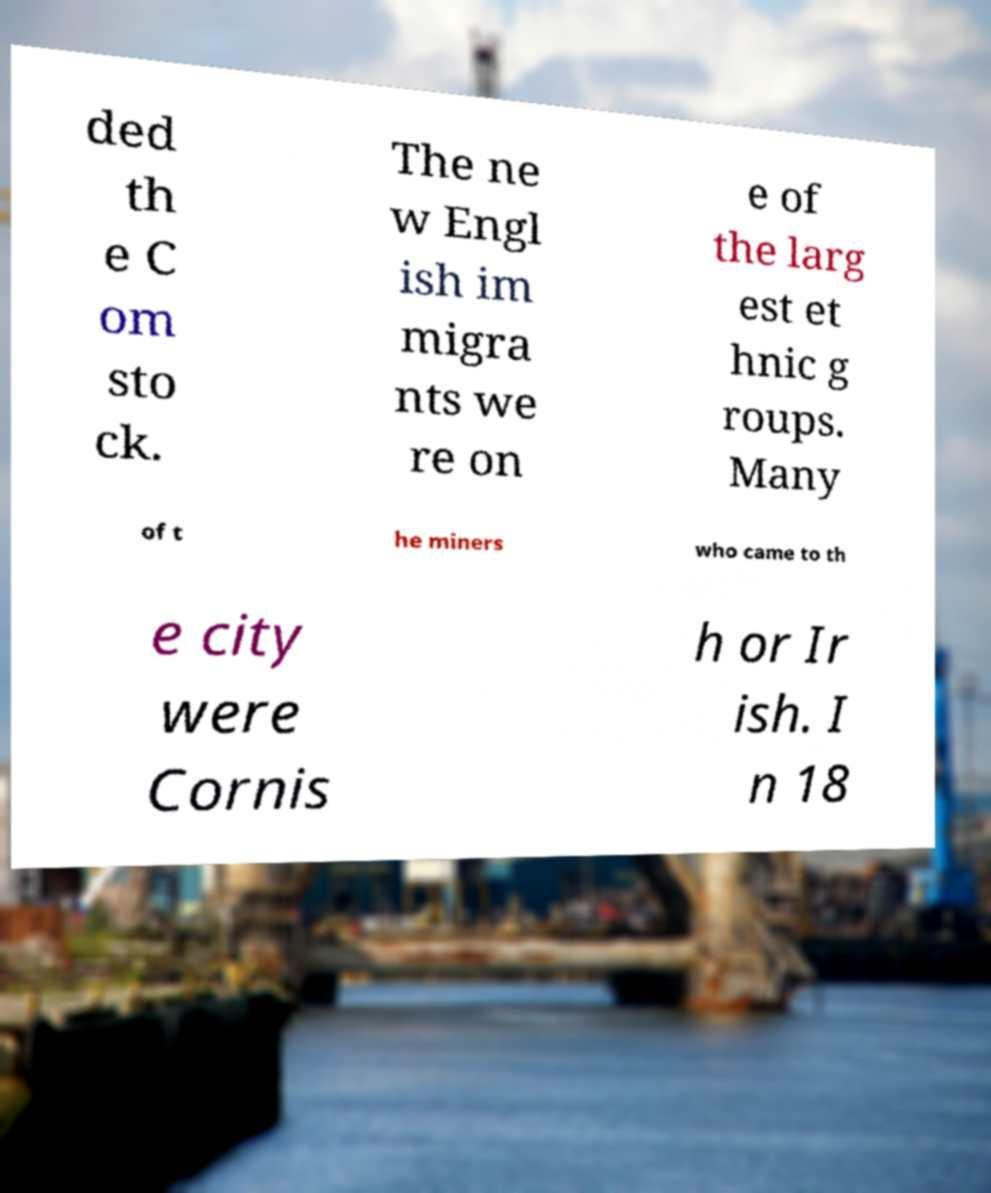There's text embedded in this image that I need extracted. Can you transcribe it verbatim? ded th e C om sto ck. The ne w Engl ish im migra nts we re on e of the larg est et hnic g roups. Many of t he miners who came to th e city were Cornis h or Ir ish. I n 18 